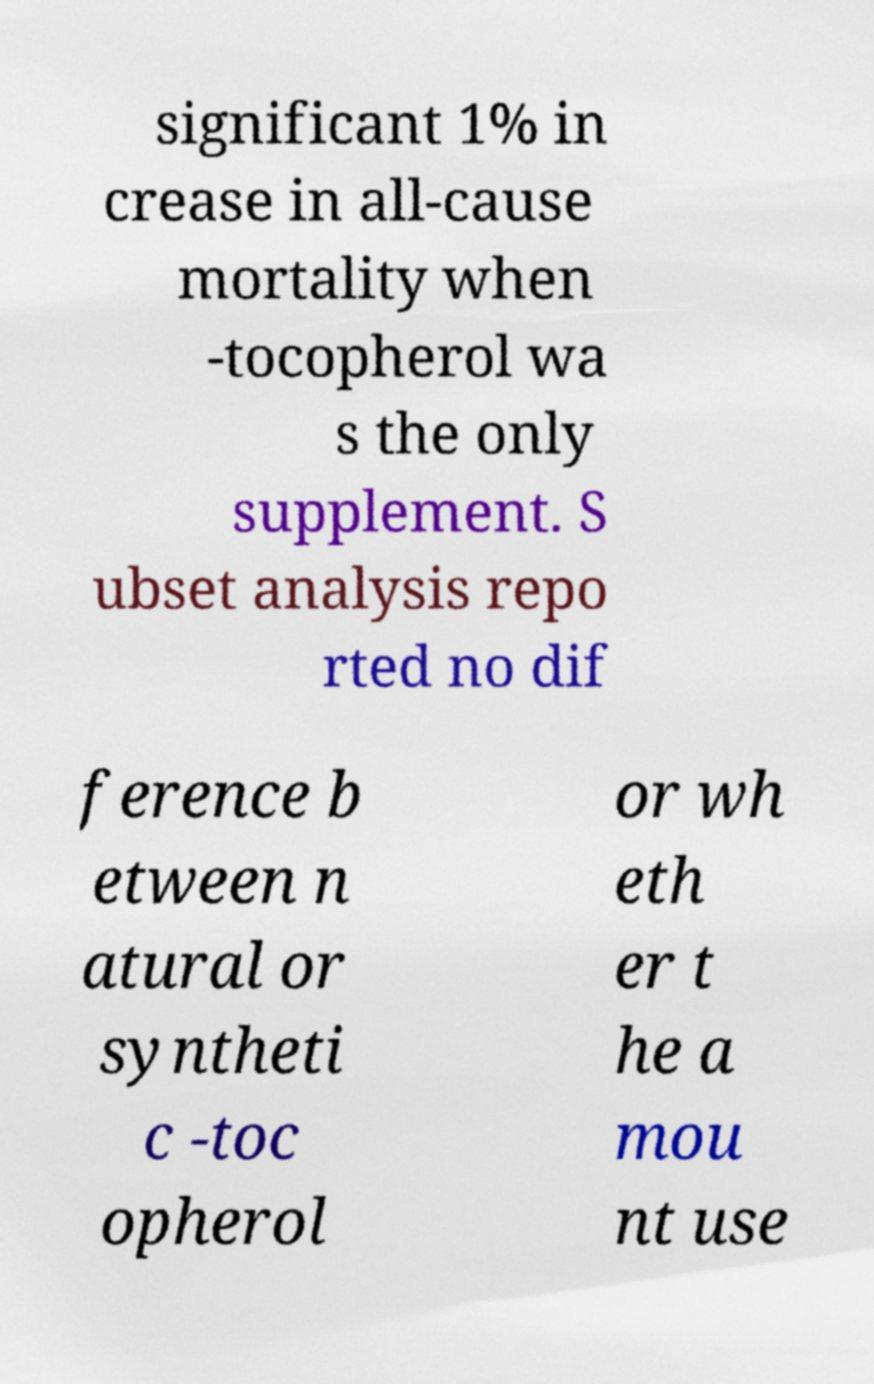There's text embedded in this image that I need extracted. Can you transcribe it verbatim? significant 1% in crease in all-cause mortality when -tocopherol wa s the only supplement. S ubset analysis repo rted no dif ference b etween n atural or syntheti c -toc opherol or wh eth er t he a mou nt use 